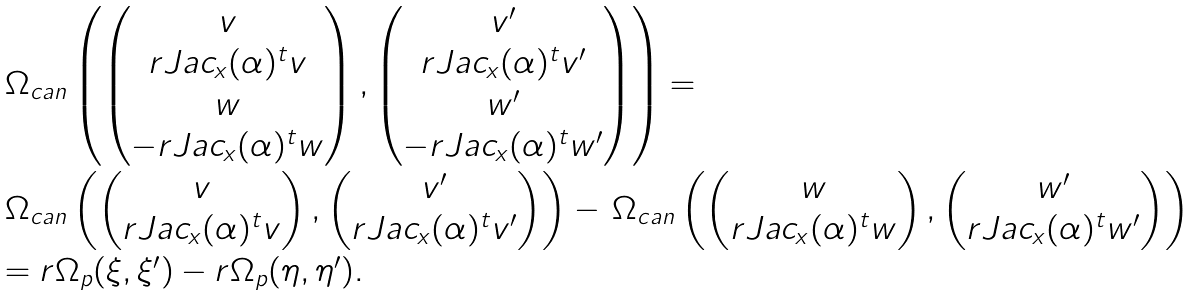Convert formula to latex. <formula><loc_0><loc_0><loc_500><loc_500>\begin{array} { l c } \Omega _ { c a n } \left ( \begin{pmatrix} v \\ r J a c _ { x } ( \alpha ) ^ { t } v \\ w \\ - r J a c _ { x } ( \alpha ) ^ { t } w \end{pmatrix} , \begin{pmatrix} v ^ { \prime } \\ r J a c _ { x } ( \alpha ) ^ { t } v ^ { \prime } \\ w ^ { \prime } \\ - r J a c _ { x } ( \alpha ) ^ { t } w ^ { \prime } \end{pmatrix} \right ) = & \\ \Omega _ { c a n } \left ( \begin{pmatrix} v \\ r J a c _ { x } ( \alpha ) ^ { t } v \end{pmatrix} , \begin{pmatrix} v ^ { \prime } \\ r J a c _ { x } ( \alpha ) ^ { t } v ^ { \prime } \end{pmatrix} \right ) - \, \Omega _ { c a n } \left ( \begin{pmatrix} w \\ r J a c _ { x } ( \alpha ) ^ { t } w \end{pmatrix} , \begin{pmatrix} w ^ { \prime } \\ r J a c _ { x } ( \alpha ) ^ { t } w ^ { \prime } \end{pmatrix} \right ) & \\ = r \Omega _ { p } ( \xi , \xi ^ { \prime } ) - r \Omega _ { p } ( \eta , \eta ^ { \prime } ) . \end{array}</formula> 